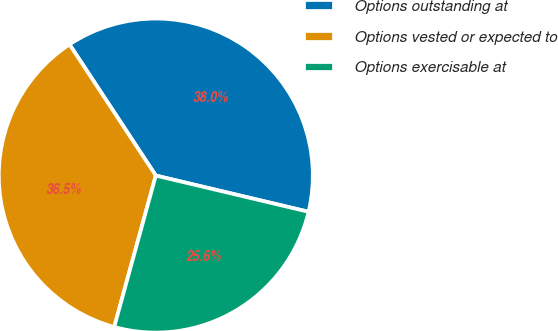Convert chart to OTSL. <chart><loc_0><loc_0><loc_500><loc_500><pie_chart><fcel>Options outstanding at<fcel>Options vested or expected to<fcel>Options exercisable at<nl><fcel>37.97%<fcel>36.47%<fcel>25.56%<nl></chart> 